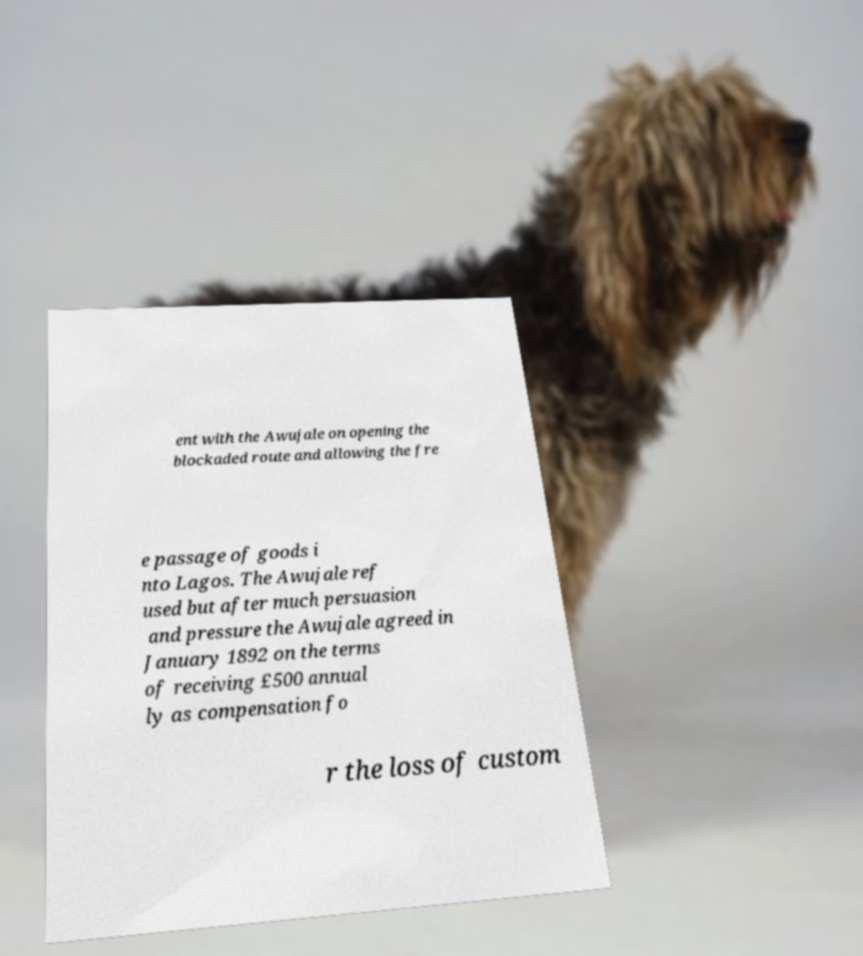Can you read and provide the text displayed in the image?This photo seems to have some interesting text. Can you extract and type it out for me? ent with the Awujale on opening the blockaded route and allowing the fre e passage of goods i nto Lagos. The Awujale ref used but after much persuasion and pressure the Awujale agreed in January 1892 on the terms of receiving £500 annual ly as compensation fo r the loss of custom 